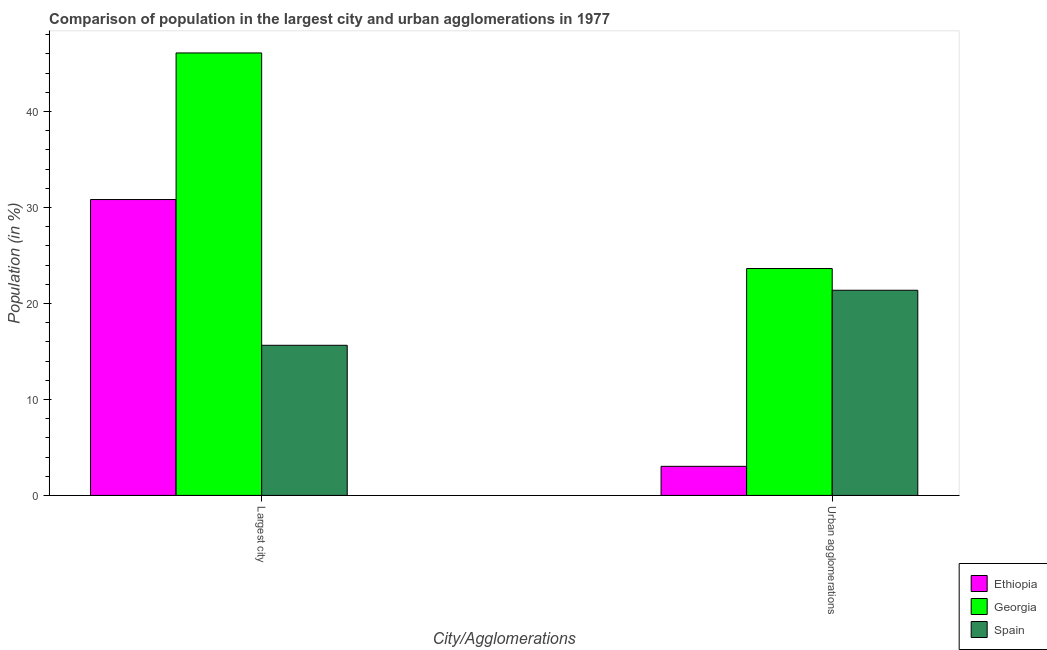How many groups of bars are there?
Provide a succinct answer. 2. Are the number of bars per tick equal to the number of legend labels?
Ensure brevity in your answer.  Yes. What is the label of the 2nd group of bars from the left?
Your answer should be compact. Urban agglomerations. What is the population in urban agglomerations in Georgia?
Your answer should be compact. 23.63. Across all countries, what is the maximum population in the largest city?
Make the answer very short. 46.09. Across all countries, what is the minimum population in urban agglomerations?
Give a very brief answer. 3.03. In which country was the population in urban agglomerations maximum?
Your answer should be very brief. Georgia. In which country was the population in urban agglomerations minimum?
Give a very brief answer. Ethiopia. What is the total population in urban agglomerations in the graph?
Your answer should be compact. 48.04. What is the difference between the population in the largest city in Georgia and that in Ethiopia?
Ensure brevity in your answer.  15.27. What is the difference between the population in urban agglomerations in Ethiopia and the population in the largest city in Georgia?
Your response must be concise. -43.06. What is the average population in the largest city per country?
Ensure brevity in your answer.  30.85. What is the difference between the population in the largest city and population in urban agglomerations in Ethiopia?
Provide a short and direct response. 27.79. What is the ratio of the population in urban agglomerations in Georgia to that in Ethiopia?
Give a very brief answer. 7.8. Is the population in the largest city in Ethiopia less than that in Spain?
Ensure brevity in your answer.  No. In how many countries, is the population in urban agglomerations greater than the average population in urban agglomerations taken over all countries?
Offer a very short reply. 2. What does the 2nd bar from the left in Urban agglomerations represents?
Your answer should be compact. Georgia. What does the 3rd bar from the right in Urban agglomerations represents?
Your answer should be compact. Ethiopia. Are all the bars in the graph horizontal?
Your answer should be very brief. No. How many countries are there in the graph?
Ensure brevity in your answer.  3. What is the difference between two consecutive major ticks on the Y-axis?
Offer a very short reply. 10. Are the values on the major ticks of Y-axis written in scientific E-notation?
Your answer should be very brief. No. Does the graph contain grids?
Give a very brief answer. No. What is the title of the graph?
Your answer should be very brief. Comparison of population in the largest city and urban agglomerations in 1977. Does "Iraq" appear as one of the legend labels in the graph?
Give a very brief answer. No. What is the label or title of the X-axis?
Ensure brevity in your answer.  City/Agglomerations. What is the Population (in %) of Ethiopia in Largest city?
Your response must be concise. 30.82. What is the Population (in %) of Georgia in Largest city?
Provide a succinct answer. 46.09. What is the Population (in %) of Spain in Largest city?
Ensure brevity in your answer.  15.64. What is the Population (in %) of Ethiopia in Urban agglomerations?
Your answer should be very brief. 3.03. What is the Population (in %) of Georgia in Urban agglomerations?
Your response must be concise. 23.63. What is the Population (in %) of Spain in Urban agglomerations?
Offer a terse response. 21.37. Across all City/Agglomerations, what is the maximum Population (in %) in Ethiopia?
Provide a succinct answer. 30.82. Across all City/Agglomerations, what is the maximum Population (in %) of Georgia?
Your answer should be very brief. 46.09. Across all City/Agglomerations, what is the maximum Population (in %) of Spain?
Your response must be concise. 21.37. Across all City/Agglomerations, what is the minimum Population (in %) of Ethiopia?
Give a very brief answer. 3.03. Across all City/Agglomerations, what is the minimum Population (in %) of Georgia?
Provide a short and direct response. 23.63. Across all City/Agglomerations, what is the minimum Population (in %) in Spain?
Provide a short and direct response. 15.64. What is the total Population (in %) of Ethiopia in the graph?
Provide a succinct answer. 33.85. What is the total Population (in %) of Georgia in the graph?
Your answer should be very brief. 69.73. What is the total Population (in %) of Spain in the graph?
Offer a very short reply. 37.01. What is the difference between the Population (in %) in Ethiopia in Largest city and that in Urban agglomerations?
Keep it short and to the point. 27.79. What is the difference between the Population (in %) in Georgia in Largest city and that in Urban agglomerations?
Provide a succinct answer. 22.46. What is the difference between the Population (in %) of Spain in Largest city and that in Urban agglomerations?
Your answer should be compact. -5.73. What is the difference between the Population (in %) in Ethiopia in Largest city and the Population (in %) in Georgia in Urban agglomerations?
Your answer should be very brief. 7.19. What is the difference between the Population (in %) in Ethiopia in Largest city and the Population (in %) in Spain in Urban agglomerations?
Ensure brevity in your answer.  9.45. What is the difference between the Population (in %) of Georgia in Largest city and the Population (in %) of Spain in Urban agglomerations?
Your response must be concise. 24.72. What is the average Population (in %) of Ethiopia per City/Agglomerations?
Your response must be concise. 16.93. What is the average Population (in %) in Georgia per City/Agglomerations?
Keep it short and to the point. 34.86. What is the average Population (in %) in Spain per City/Agglomerations?
Keep it short and to the point. 18.5. What is the difference between the Population (in %) of Ethiopia and Population (in %) of Georgia in Largest city?
Provide a short and direct response. -15.27. What is the difference between the Population (in %) in Ethiopia and Population (in %) in Spain in Largest city?
Offer a very short reply. 15.18. What is the difference between the Population (in %) of Georgia and Population (in %) of Spain in Largest city?
Provide a succinct answer. 30.45. What is the difference between the Population (in %) of Ethiopia and Population (in %) of Georgia in Urban agglomerations?
Your response must be concise. -20.61. What is the difference between the Population (in %) in Ethiopia and Population (in %) in Spain in Urban agglomerations?
Your answer should be compact. -18.34. What is the difference between the Population (in %) of Georgia and Population (in %) of Spain in Urban agglomerations?
Your answer should be very brief. 2.26. What is the ratio of the Population (in %) in Ethiopia in Largest city to that in Urban agglomerations?
Offer a terse response. 10.17. What is the ratio of the Population (in %) of Georgia in Largest city to that in Urban agglomerations?
Provide a succinct answer. 1.95. What is the ratio of the Population (in %) in Spain in Largest city to that in Urban agglomerations?
Your response must be concise. 0.73. What is the difference between the highest and the second highest Population (in %) in Ethiopia?
Your answer should be very brief. 27.79. What is the difference between the highest and the second highest Population (in %) of Georgia?
Make the answer very short. 22.46. What is the difference between the highest and the second highest Population (in %) of Spain?
Your response must be concise. 5.73. What is the difference between the highest and the lowest Population (in %) in Ethiopia?
Provide a short and direct response. 27.79. What is the difference between the highest and the lowest Population (in %) of Georgia?
Make the answer very short. 22.46. What is the difference between the highest and the lowest Population (in %) of Spain?
Offer a terse response. 5.73. 